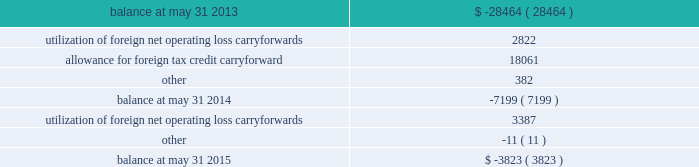Undistributed earnings of $ 696.9 million from certain foreign subsidiaries are considered to be permanently reinvested abroad and will not be repatriated to the united states in the foreseeable future .
Because those earnings are considered to be indefinitely reinvested , no domestic federal or state deferred income taxes have been provided thereon .
If we were to make a distribution of any portion of those earnings in the form of dividends or otherwise , we would be subject to both u.s .
Income taxes ( subject to an adjustment for foreign tax credits ) and withholding taxes payable to the various foreign jurisdictions .
Because of the availability of u.s .
Foreign tax credit carryforwards , it is not practicable to determine the domestic federal income tax liability that would be payable if such earnings were no longer considered to be reinvested indefinitely .
A valuation allowance is provided against deferred tax assets when it is more likely than not that some portion or all of the deferred tax assets will not be realized .
Changes to our valuation allowance during the years ended may 31 , 2015 and 2014 are summarized below ( in thousands ) : .
Net operating loss carryforwards of foreign subsidiaries totaling $ 12.4 million and u.s .
Net operating loss carryforwards previously acquired totaling $ 19.8 million at may 31 , 2015 will expire between may 31 , 2017 and may 31 , 2033 if not utilized .
Capital loss carryforwards of u.s .
Subsidiaries totaling $ 4.7 million will expire if not utilized by may 31 , 2017 .
Tax credit carryforwards totaling $ 8.4 million at may 31 , 2015 will expire between may 31 , 2017 and may 31 , 2023 if not utilized .
We conduct business globally and file income tax returns in the u.s .
Federal jurisdiction and various state and foreign jurisdictions .
In the normal course of business , we are subject to examination by taxing authorities around the world .
As a result of events that occurred in the fourth quarter of the year ended may 31 , 2015 , management concluded that it was more likely than not that the tax positions in a foreign jurisdiction , for which we had recorded estimated liabilities of $ 65.6 million in other noncurrent liabilities on our consolidated balance sheet , would be sustained on their technical merits based on information available as of may 31 , 2015 .
Therefore , the liability and corresponding deferred tax assets were eliminated as of may 31 , 2015 .
The uncertain tax positions have been subject to an ongoing examination in that foreign jurisdiction by the tax authority .
Discussions and correspondence between the tax authority and us during the fourth quarter indicated that the likelihood of the positions being sustained had increased .
Subsequent to may 31 , 2015 , we received a final closure notice regarding the examination resulting in no adjustments to taxable income related to this matter for the tax returns filed for the periods ended may 31 , 2010 through may 31 , 2013 .
The unrecognized tax benefits were effectively settled with this final closure notice .
We are no longer subjected to state income tax examinations for years ended on or before may 31 , 2008 , u.s .
Federal income tax examinations for fiscal years prior to 2012 and united kingdom federal income tax examinations for years ended on or before may 31 , 2013 .
78 2013 global payments inc .
| 2015 form 10-k annual report .
What is the total loss carryforwards? 
Computations: ((12.4 + 19.8) + 4.7)
Answer: 36.9. 